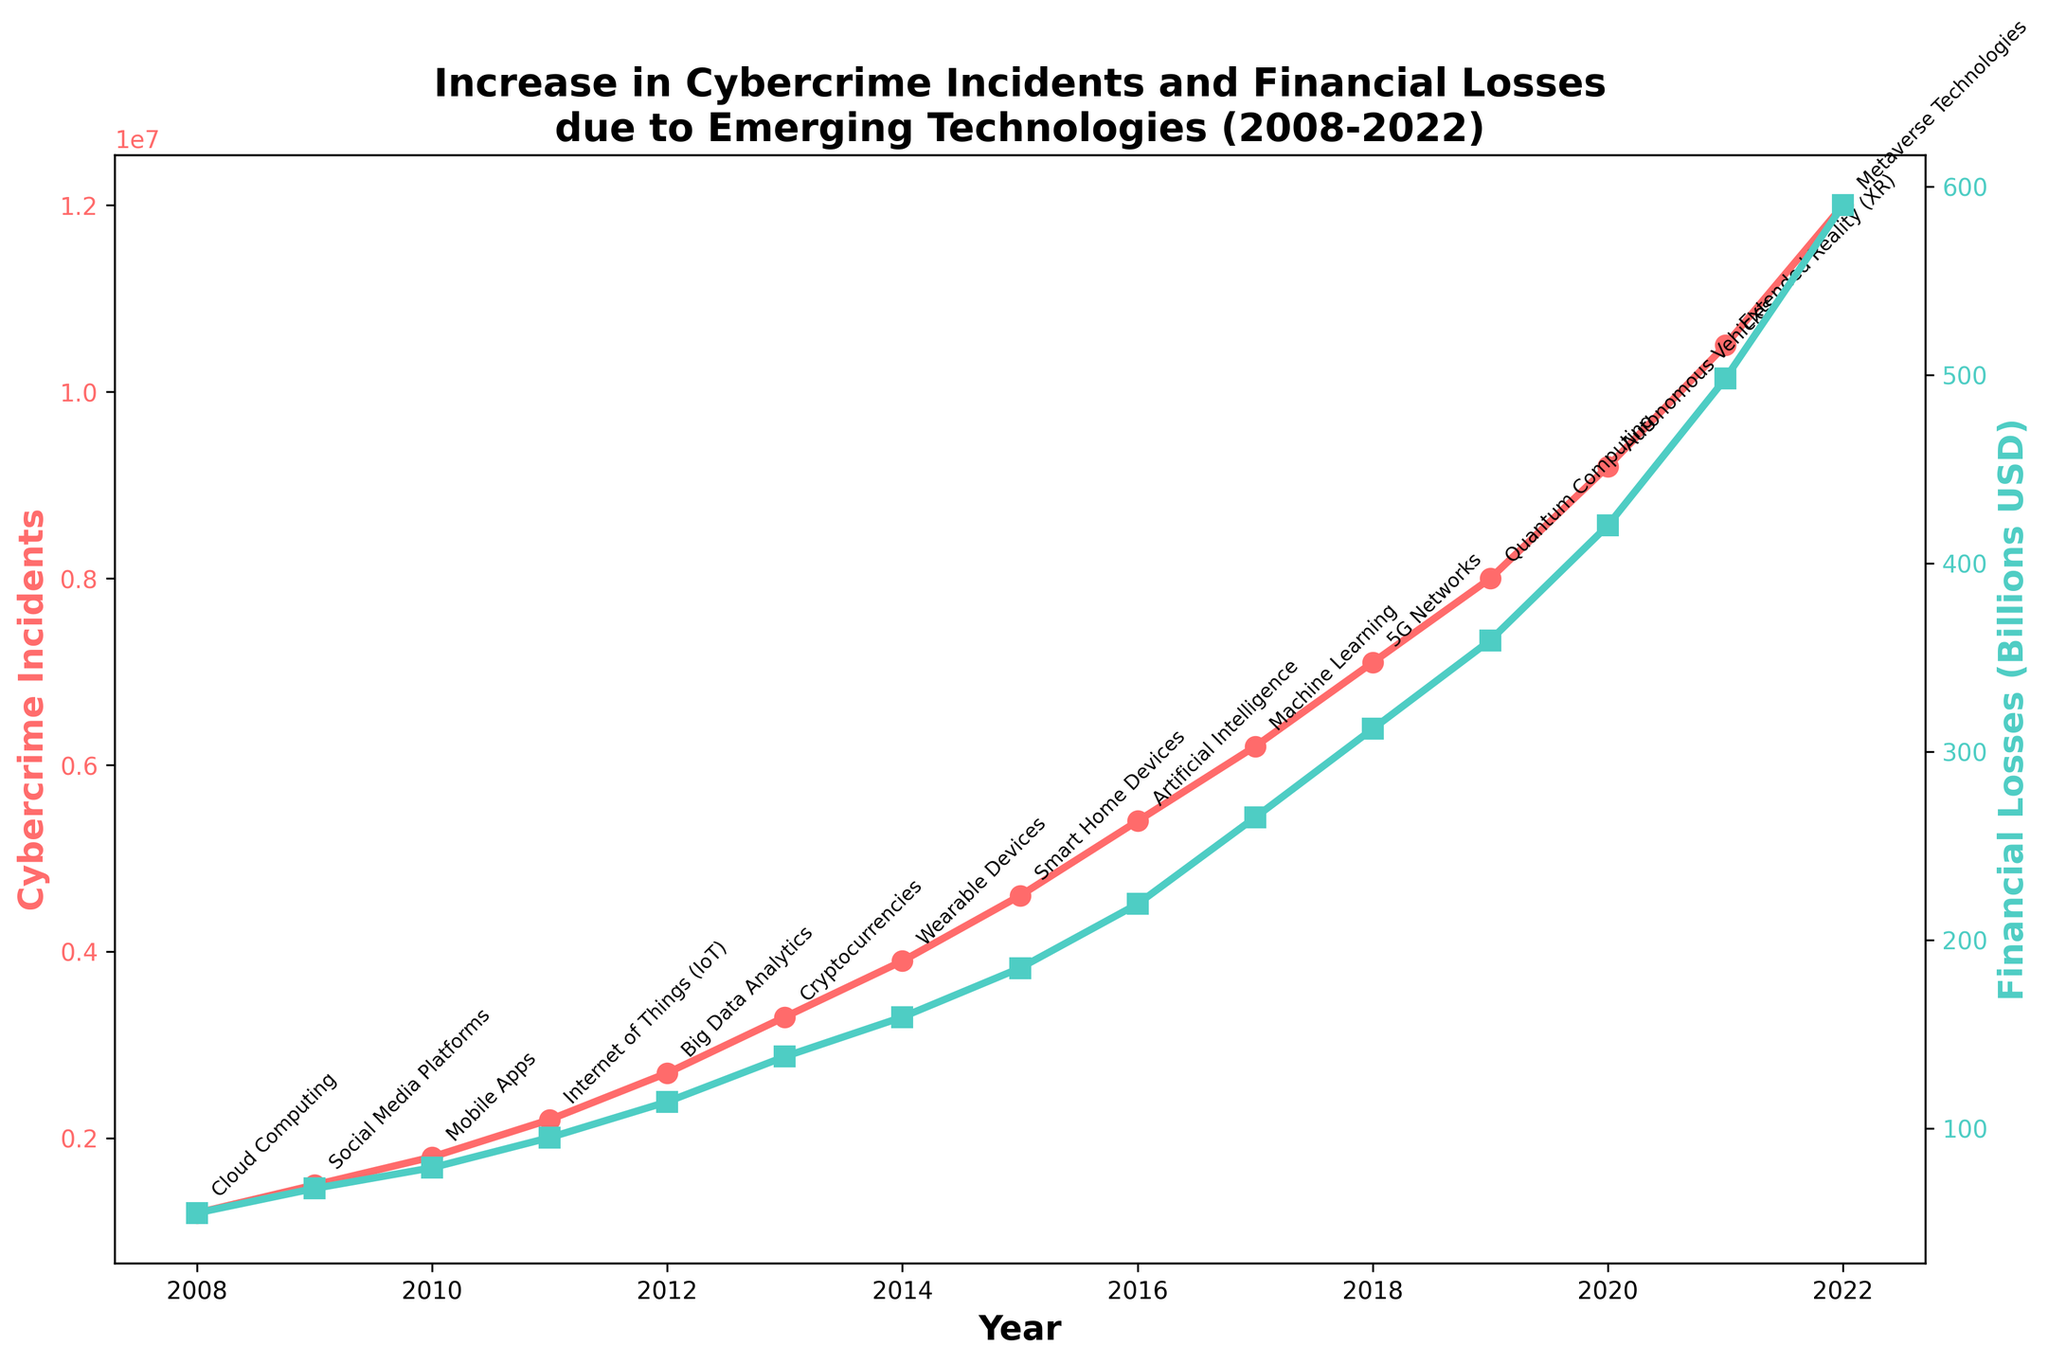Which year saw the highest number of cybercrime incidents? The red line representing cybercrime incidents peaks at 2022, indicating the highest number of incidents.
Answer: 2022 What is the overall trend in financial losses over the years? The green line showing financial losses consistently rises from 2008 to 2022, indicating an increasing trend.
Answer: Increasing How do the cybercrime incidents in 2020 compare to those in 2018? In 2020, the number of cybercrime incidents is 9,200,000, which is greater than the 7,100,000 incidents in 2018.
Answer: 2020 > 2018 What was the financial loss in 2015, and how does it compare to the loss in 2012? The financial loss in 2015 was $185 billion, which is greater than the $114 billion loss in 2012.
Answer: 2015 > 2012 Which year experienced the sharpest increase in financial losses? From examining the green line, the largest single-year increase can be noticed between 2019 ($359 billion) and 2020 ($420 billion), an increase of $61 billion.
Answer: 2019 to 2020 How much did financial losses increase from 2008 to 2022? Financial losses rose from $55 billion in 2008 to $590 billion in 2022, an increase of $535 billion.
Answer: $535 billion Which technology trend corresponds to the highest financial losses in the chart? The highest financial losses noted in 2022 correlate with "Metaverse Technologies."
Answer: Metaverse Technologies What is the average number of cybercrime incidents from 2008 to 2012? Summing the number of incidents from 2008 (1,200,000) to 2012 (2,700,000) gives a total of 9,600,000. Dividing by 5 years, the average is 1,920,000.
Answer: 1,920,000 By what factor did cybercrime incidents increase from 2008 to 2022? Cybercrime incidents increased from 1,200,000 in 2008 to 12,000,000 in 2022, a factor of 10.
Answer: Factor of 10 